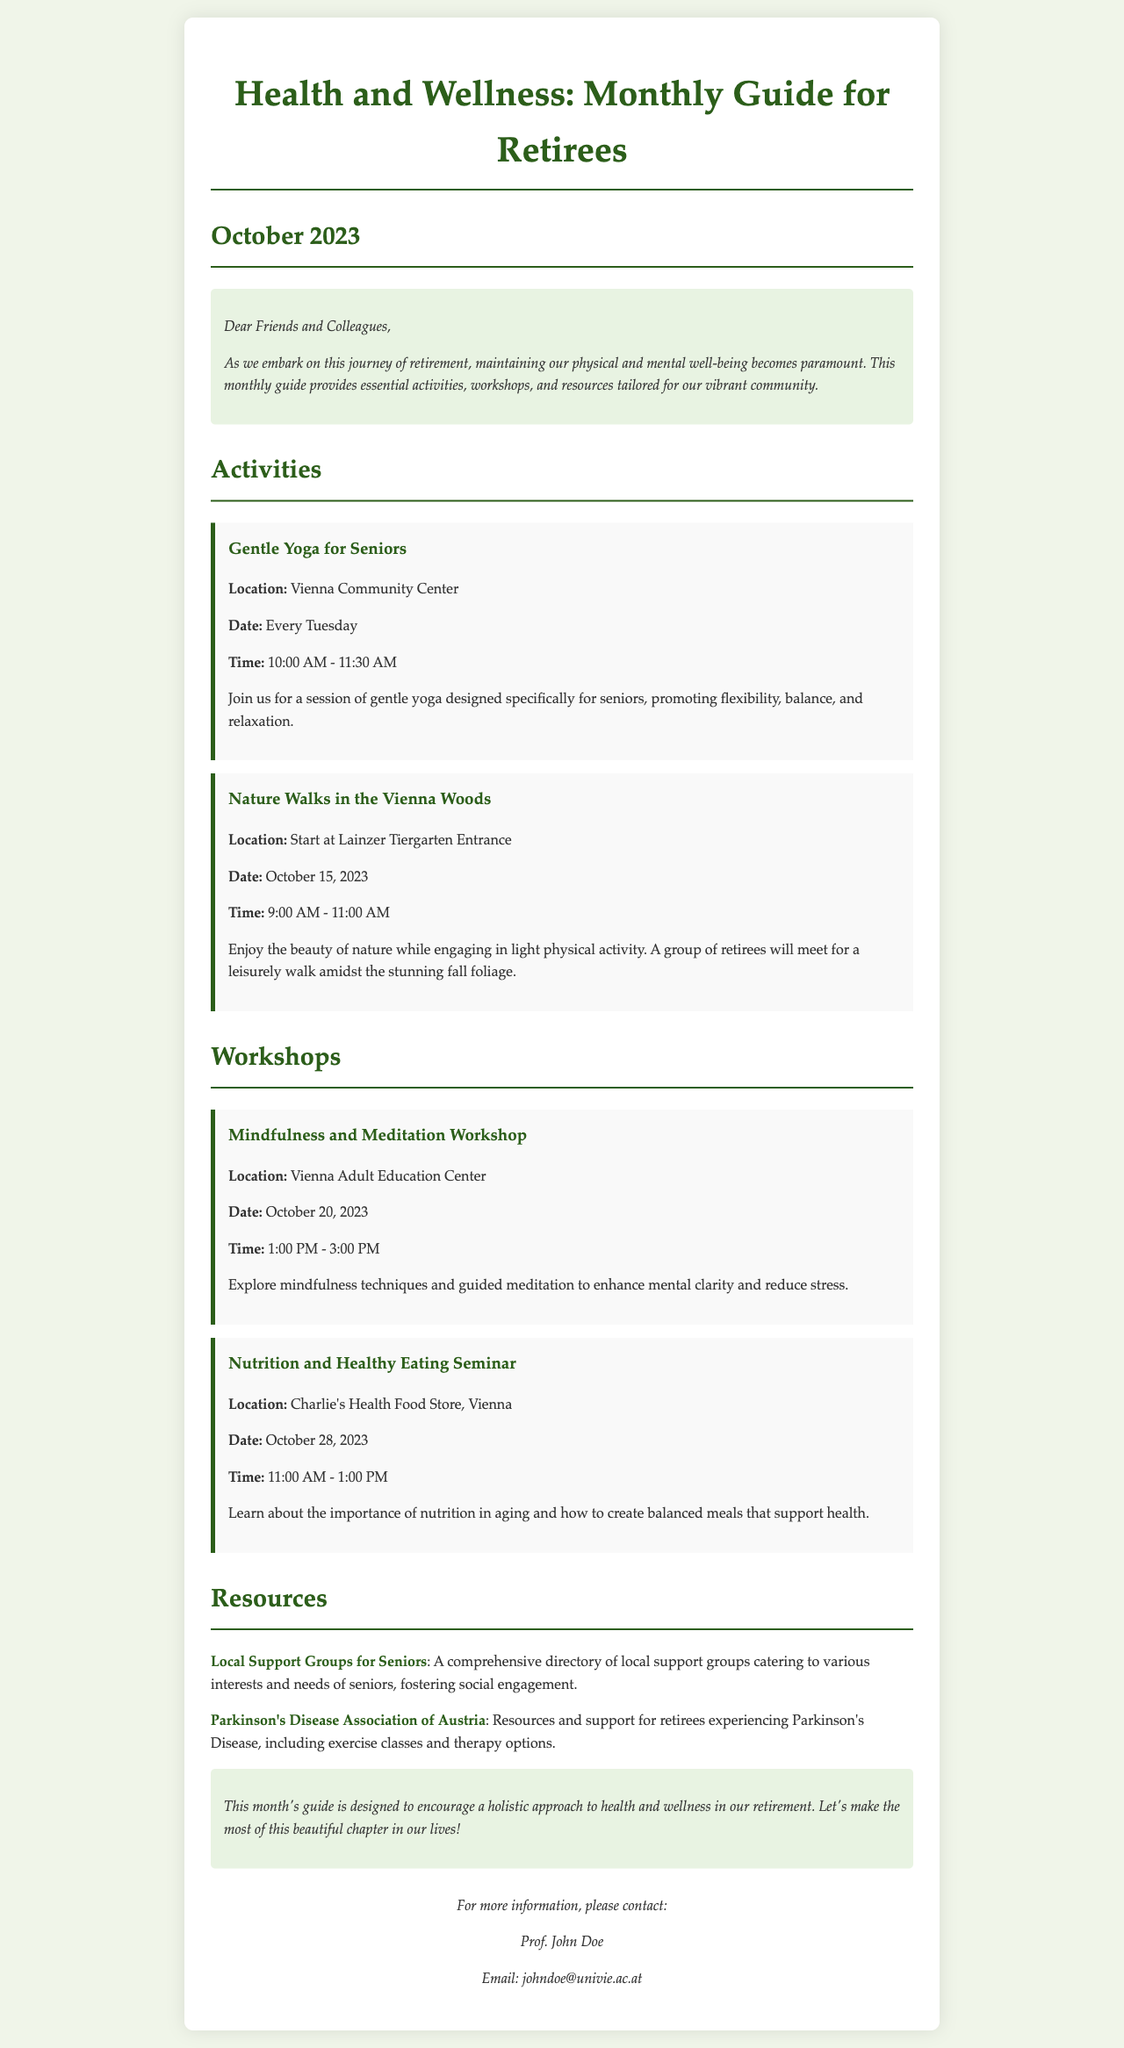What is the title of the guide? The title is indicated at the top of the document, specifically as the main heading.
Answer: Health and Wellness: Monthly Guide for Retirees What day is the Mindfulness and Meditation Workshop scheduled for? The date is listed under the workshop heading and specifies when the event will take place.
Answer: October 20, 2023 Where is the Gentle Yoga for Seniors held? The location is provided in the event description, indicating where participants can attend the session.
Answer: Vienna Community Center What time does the Nutrition and Healthy Eating Seminar start? The start time is included in the event details of the workshop section of the guide.
Answer: 11:00 AM What is the main focus of the Nature Walks in the Vienna Woods event? The event description outlines the primary activity and purpose of the gathering.
Answer: Light physical activity Which resource is related to Parkinson's Disease? The resource section lists links addressing specific health concerns, making it clear which one relates to Parkinson's Disease.
Answer: Parkinson's Disease Association of Austria How often is the Gentle Yoga for Seniors class offered? The frequency of the class is specified in the event details of that particular activity.
Answer: Every Tuesday Who is the contact person for more information? The contact information section names the individual responsible for answering inquiries related to the guide.
Answer: Prof. John Doe 